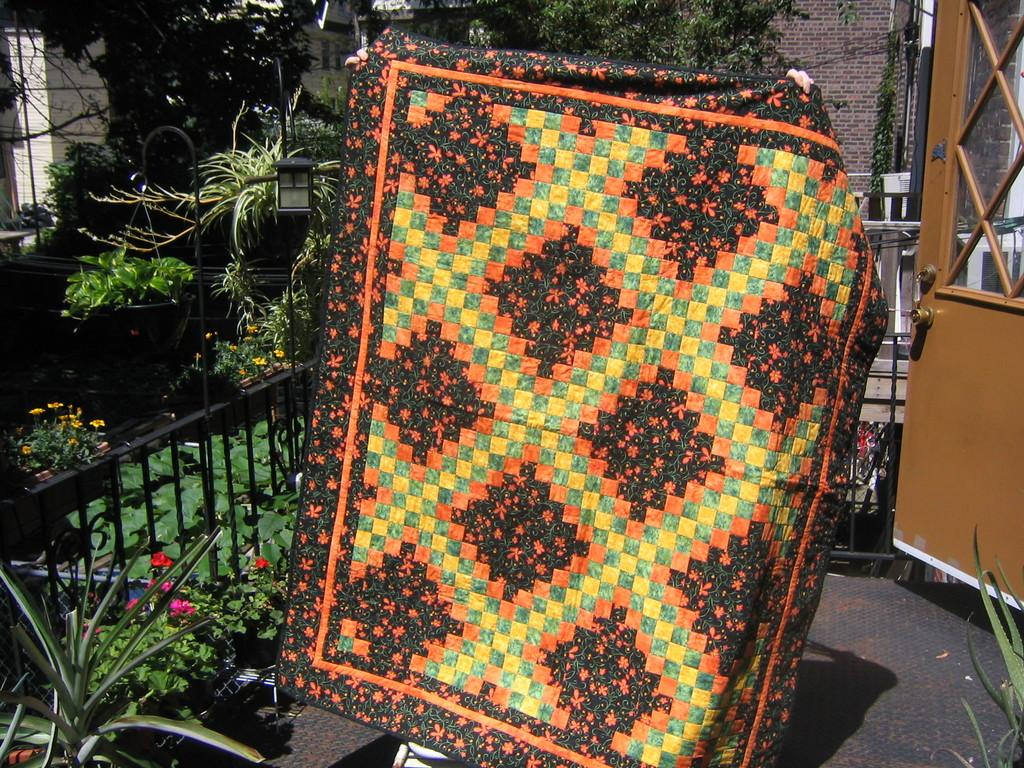What is being held by the human hands in the image? Human hands are holding a carpet in the image. What type of barrier can be seen in the image? There is a fence in the image. What type of entrance is present in the image? There is a door in the image. What type of vegetation is present in the image? Flower plants, grass, and trees are present in the image. What type of structure is visible in the image? There is a brick wall in the image. What type of surface is visible in the image? The floor is visible in the image. What type of face can be seen on the carpet in the image? There is no face present on the carpet in the image. What type of current is flowing through the fence in the image? There is no current present in the image, as it is a static photograph. 